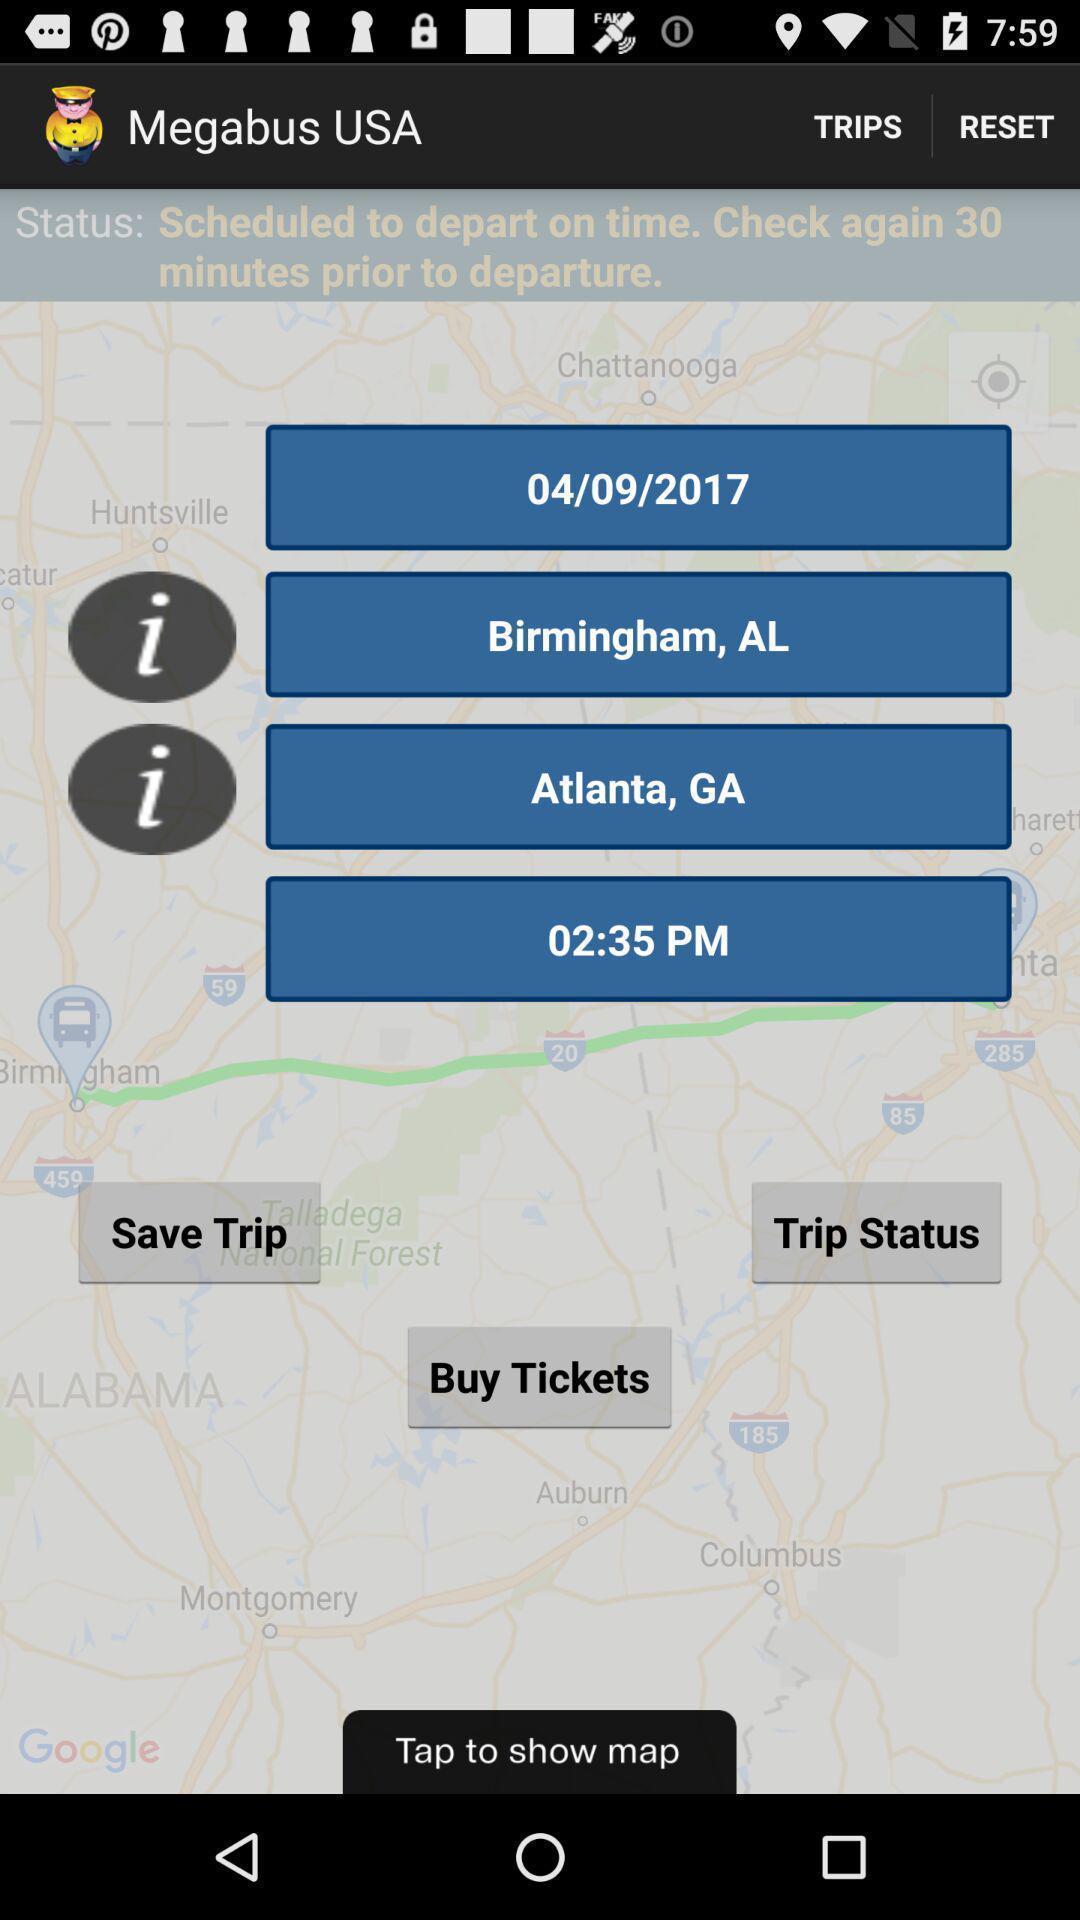Give me a narrative description of this picture. Page with various options in a service application. 